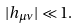<formula> <loc_0><loc_0><loc_500><loc_500>| h _ { \mu \nu } | \ll 1 .</formula> 